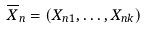<formula> <loc_0><loc_0><loc_500><loc_500>\overline { X } _ { n } = ( X _ { n 1 } , \dots , X _ { n k } )</formula> 